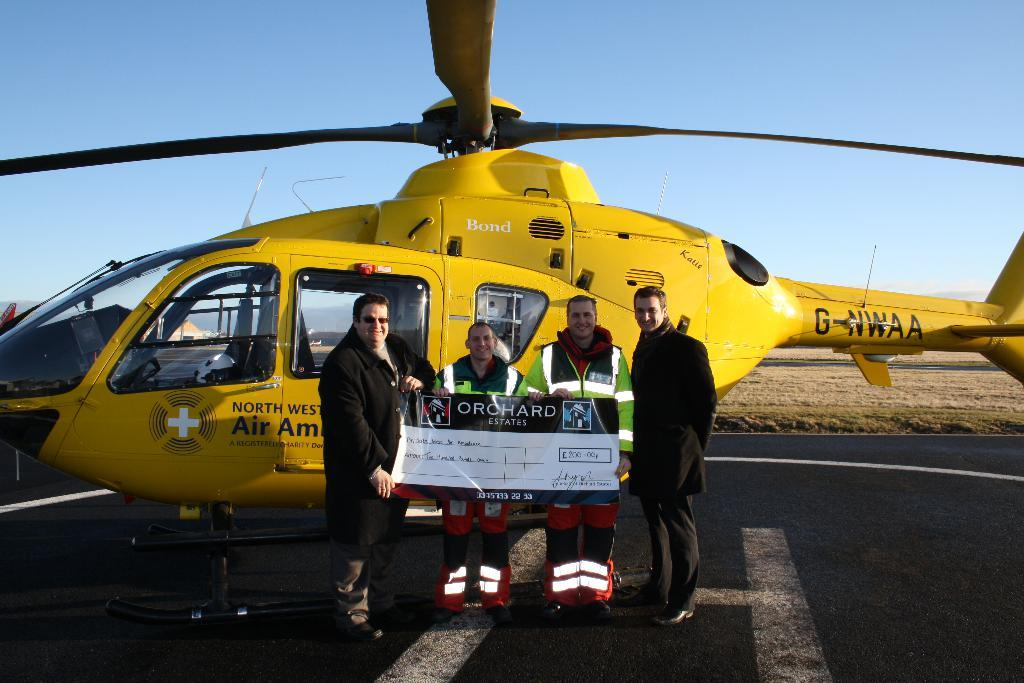How many people are in the image? There are four persons in the image. What are the persons doing in the image? The persons are standing and holding a cheque. Can you describe the background of the image? There is a yellow color helicopter behind them. What type of cap is the helicopter wearing in the image? There is no cap present in the image, as the helicopter is not a living being and therefore cannot wear a cap. 